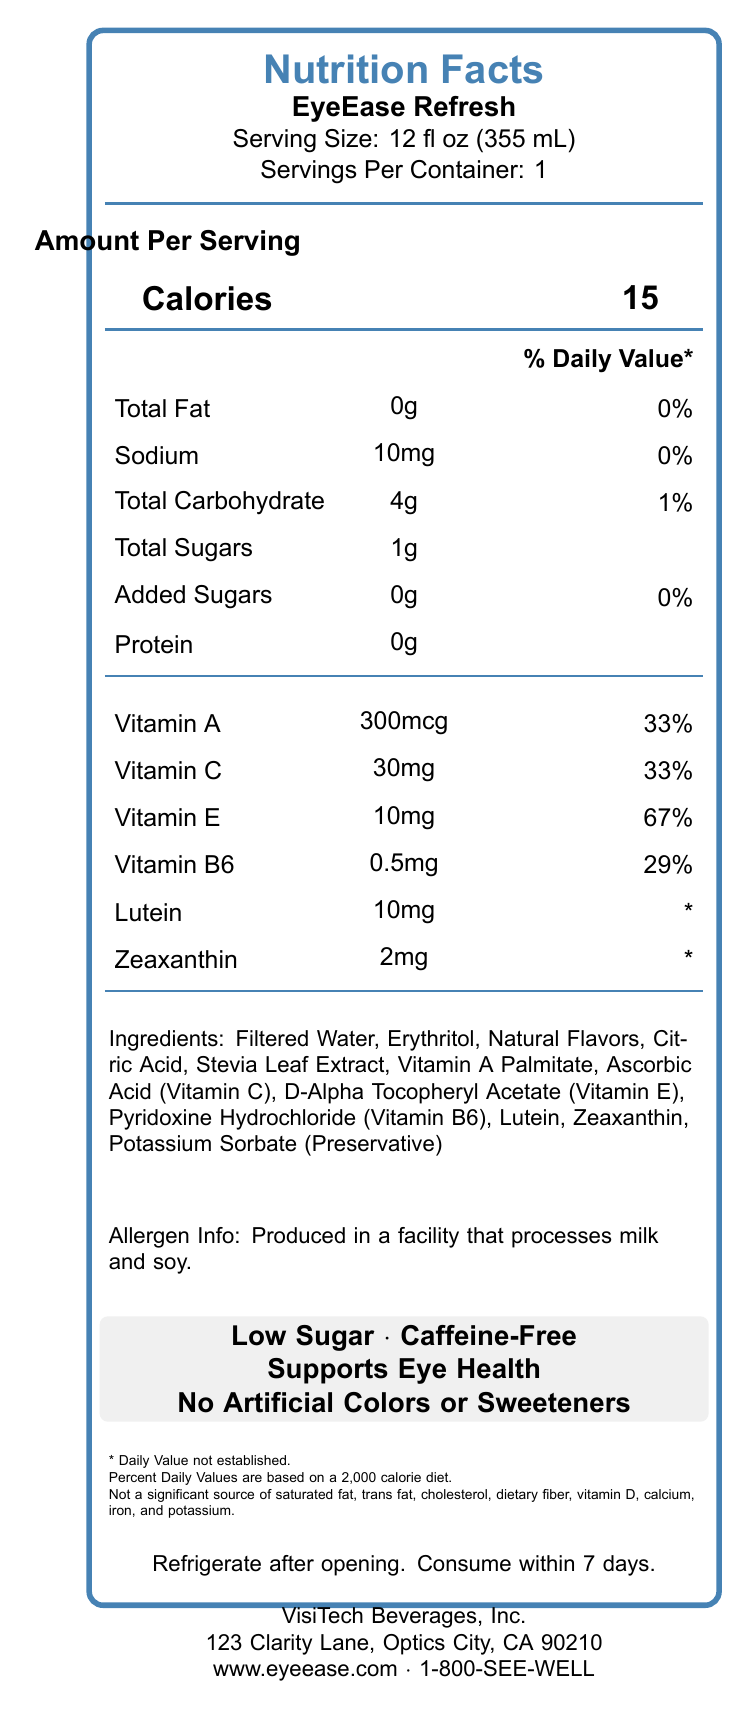what is the serving size for EyeEase Refresh? The serving size is explicitly mentioned in the document.
Answer: 12 fl oz (355 mL) how many calories are there per serving? The calorie count per serving is clearly listed in the document.
Answer: 15 calories what is the percentage daily value of vitamin E per serving? The percentage daily value of vitamin E can be found in the nutrition facts section.
Answer: 67% how much sodium is in one serving of EyeEase Refresh? The amount of sodium is listed as 10mg per serving.
Answer: 10mg list two marketing claims mentioned on the label. The marketing claims section highlights multiple points, including "Low Sugar" and "Caffeine-Free".
Answer: Low Sugar, Caffeine-Free what ingredients are used in EyeEase Refresh? A. Aspartame, Pectin, Citric Acid B. Filtered Water, Erythritol, Citric Acid C. Sucralose, Artificial Flavors, Stevia Leaf Extract D. High Fructose Corn Syrup, Natural Flavors, Salt The ingredients list includes "Filtered Water," "Erythritol," and "Citric Acid," among others.
Answer: B what company manufactures EyeEase Refresh? A. BrightBev, Inc. B. Visionary Drinks, Inc. C. VisiTech Beverages, Inc. D. ScreenGuard Beverages, Inc. The manufacturer's name, VisiTech Beverages, Inc., is clearly shown in the document.
Answer: C is EyeEase Refresh caffeine-free? The label specifically states that the beverage is caffeine-free.
Answer: Yes summarize the main features and nutritional information of EyeEase Refresh. The document provides a detailed nutrition facts label, listing calories, vitamins, and ingredients. It also includes marketing claims and storage instructions, along with manufacturer information.
Answer: EyeEase Refresh is a low-sugar, caffeine-free beverage designed to support eye health, particularly for people who spend long hours in front of screens. The beverage has a serving size of 12 fl oz with 15 calories per serving. It contains essential vitamins like vitamin A, C, E, and B6, along with lutein and zeaxanthin. The product is free from artificial colors or sweeteners and includes ingredients like filtered water, erythritol, and stevia leaf extract. The product is produced by VisiTech Beverages, and it requires refrigeration after opening. how much protein is in a serving of EyeEase Refresh? The nutrition facts state there is 0g protein per serving.
Answer: 0g what is the daily value percentage of total carbohydrate per serving? The daily value percentage for total carbohydrate is clearly listed.
Answer: 1% if a person consumes three servings of EyeEase Refresh, how many calories will they intake? One serving has 15 calories, so three servings would have 15 * 3 = 45 calories.
Answer: 45 calories can you determine the production date of this beverage from the label? The document does not provide any information regarding the production date.
Answer: Not enough information how long is EyeEase Refresh good for after opening? The storage instructions specify that the product should be consumed within 7 days after opening.
Answer: 7 days what is the main use of EyeEase Refresh according to the label? The marketing claims include "Supports Eye Health," indicating the primary purpose of the beverage.
Answer: Supports eye health 